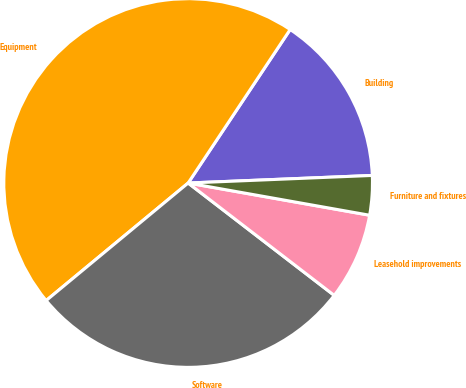<chart> <loc_0><loc_0><loc_500><loc_500><pie_chart><fcel>Building<fcel>Equipment<fcel>Software<fcel>Leasehold improvements<fcel>Furniture and fixtures<nl><fcel>15.01%<fcel>45.34%<fcel>28.56%<fcel>7.64%<fcel>3.45%<nl></chart> 